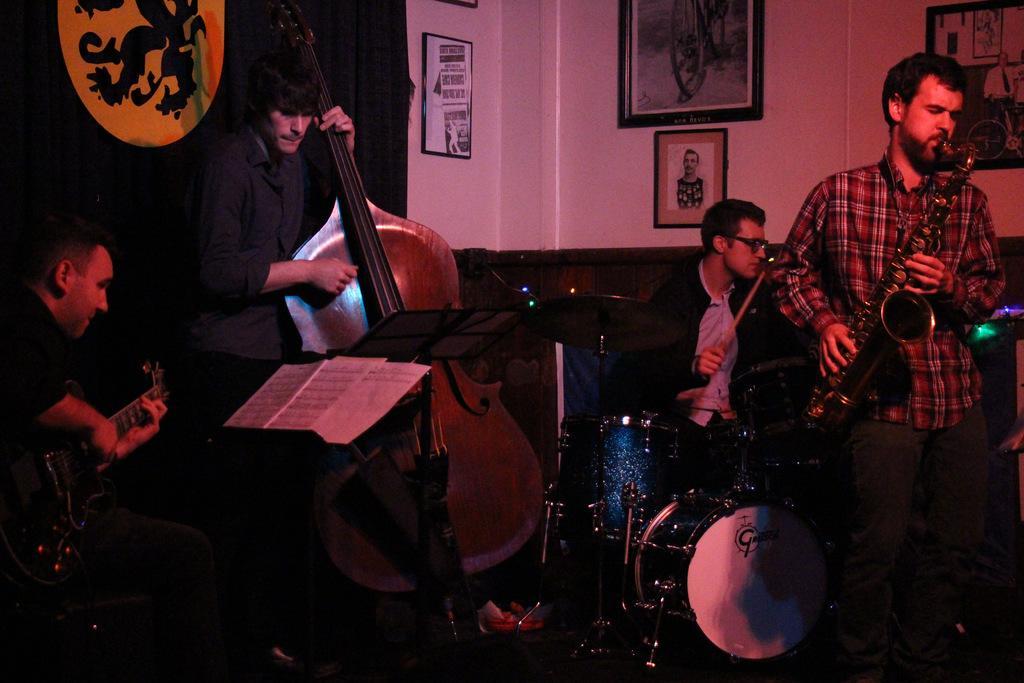Describe this image in one or two sentences. There are group of people playing music. 